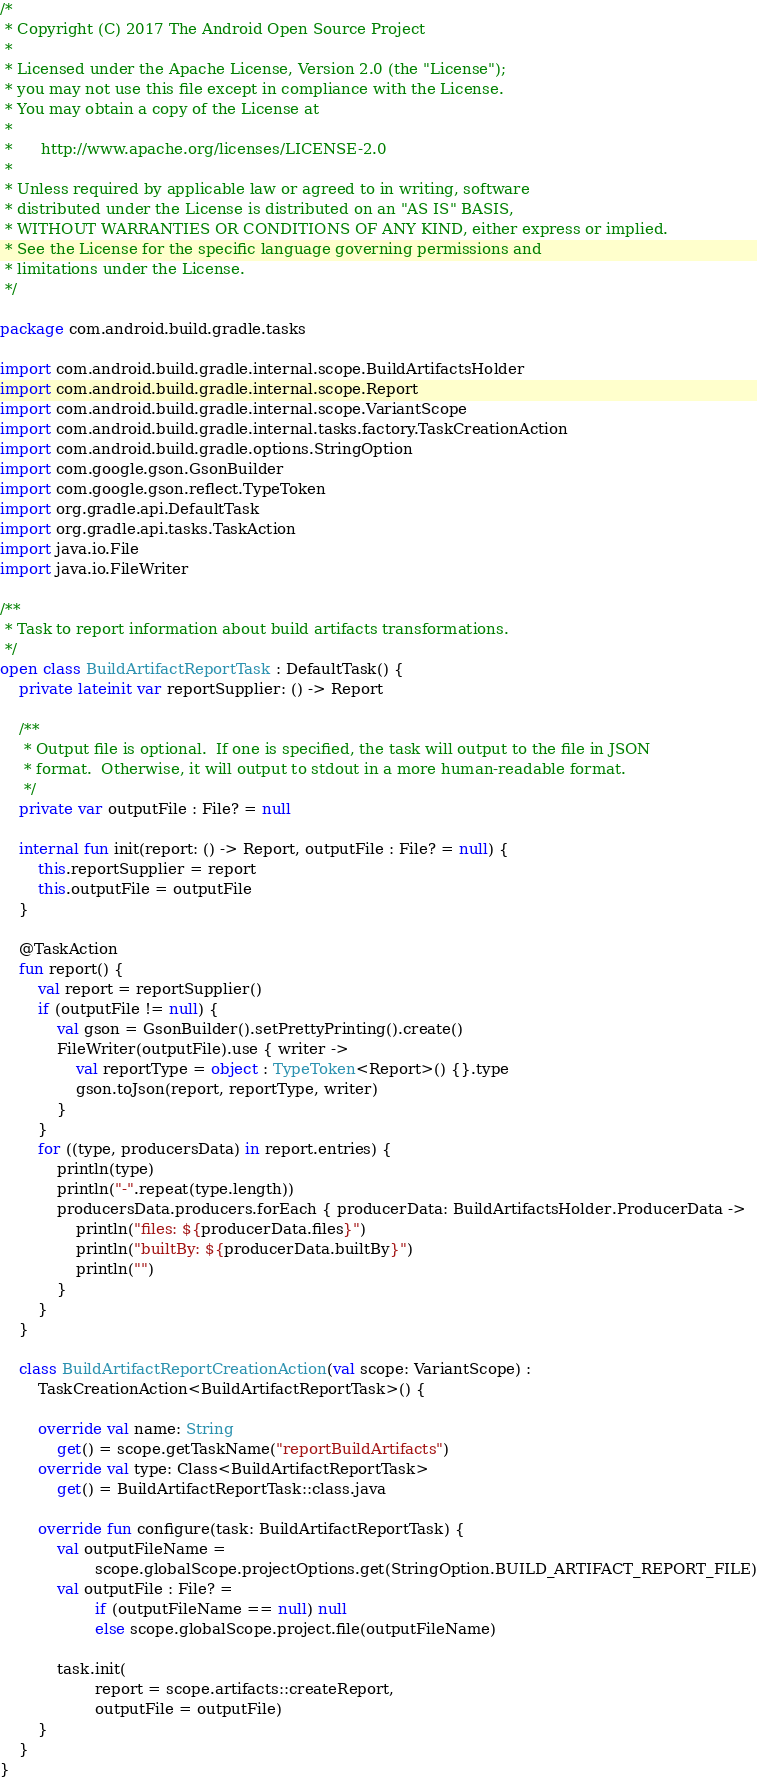<code> <loc_0><loc_0><loc_500><loc_500><_Kotlin_>/*
 * Copyright (C) 2017 The Android Open Source Project
 *
 * Licensed under the Apache License, Version 2.0 (the "License");
 * you may not use this file except in compliance with the License.
 * You may obtain a copy of the License at
 *
 *      http://www.apache.org/licenses/LICENSE-2.0
 *
 * Unless required by applicable law or agreed to in writing, software
 * distributed under the License is distributed on an "AS IS" BASIS,
 * WITHOUT WARRANTIES OR CONDITIONS OF ANY KIND, either express or implied.
 * See the License for the specific language governing permissions and
 * limitations under the License.
 */

package com.android.build.gradle.tasks

import com.android.build.gradle.internal.scope.BuildArtifactsHolder
import com.android.build.gradle.internal.scope.Report
import com.android.build.gradle.internal.scope.VariantScope
import com.android.build.gradle.internal.tasks.factory.TaskCreationAction
import com.android.build.gradle.options.StringOption
import com.google.gson.GsonBuilder
import com.google.gson.reflect.TypeToken
import org.gradle.api.DefaultTask
import org.gradle.api.tasks.TaskAction
import java.io.File
import java.io.FileWriter

/**
 * Task to report information about build artifacts transformations.
 */
open class BuildArtifactReportTask : DefaultTask() {
    private lateinit var reportSupplier: () -> Report

    /**
     * Output file is optional.  If one is specified, the task will output to the file in JSON
     * format.  Otherwise, it will output to stdout in a more human-readable format.
     */
    private var outputFile : File? = null

    internal fun init(report: () -> Report, outputFile : File? = null) {
        this.reportSupplier = report
        this.outputFile = outputFile
    }

    @TaskAction
    fun report() {
        val report = reportSupplier()
        if (outputFile != null) {
            val gson = GsonBuilder().setPrettyPrinting().create()
            FileWriter(outputFile).use { writer ->
                val reportType = object : TypeToken<Report>() {}.type
                gson.toJson(report, reportType, writer)
            }
        }
        for ((type, producersData) in report.entries) {
            println(type)
            println("-".repeat(type.length))
            producersData.producers.forEach { producerData: BuildArtifactsHolder.ProducerData ->
                println("files: ${producerData.files}")
                println("builtBy: ${producerData.builtBy}")
                println("")
            }
        }
    }

    class BuildArtifactReportCreationAction(val scope: VariantScope) :
        TaskCreationAction<BuildArtifactReportTask>() {

        override val name: String
            get() = scope.getTaskName("reportBuildArtifacts")
        override val type: Class<BuildArtifactReportTask>
            get() = BuildArtifactReportTask::class.java

        override fun configure(task: BuildArtifactReportTask) {
            val outputFileName =
                    scope.globalScope.projectOptions.get(StringOption.BUILD_ARTIFACT_REPORT_FILE)
            val outputFile : File? =
                    if (outputFileName == null) null
                    else scope.globalScope.project.file(outputFileName)

            task.init(
                    report = scope.artifacts::createReport,
                    outputFile = outputFile)
        }
    }
}

</code> 